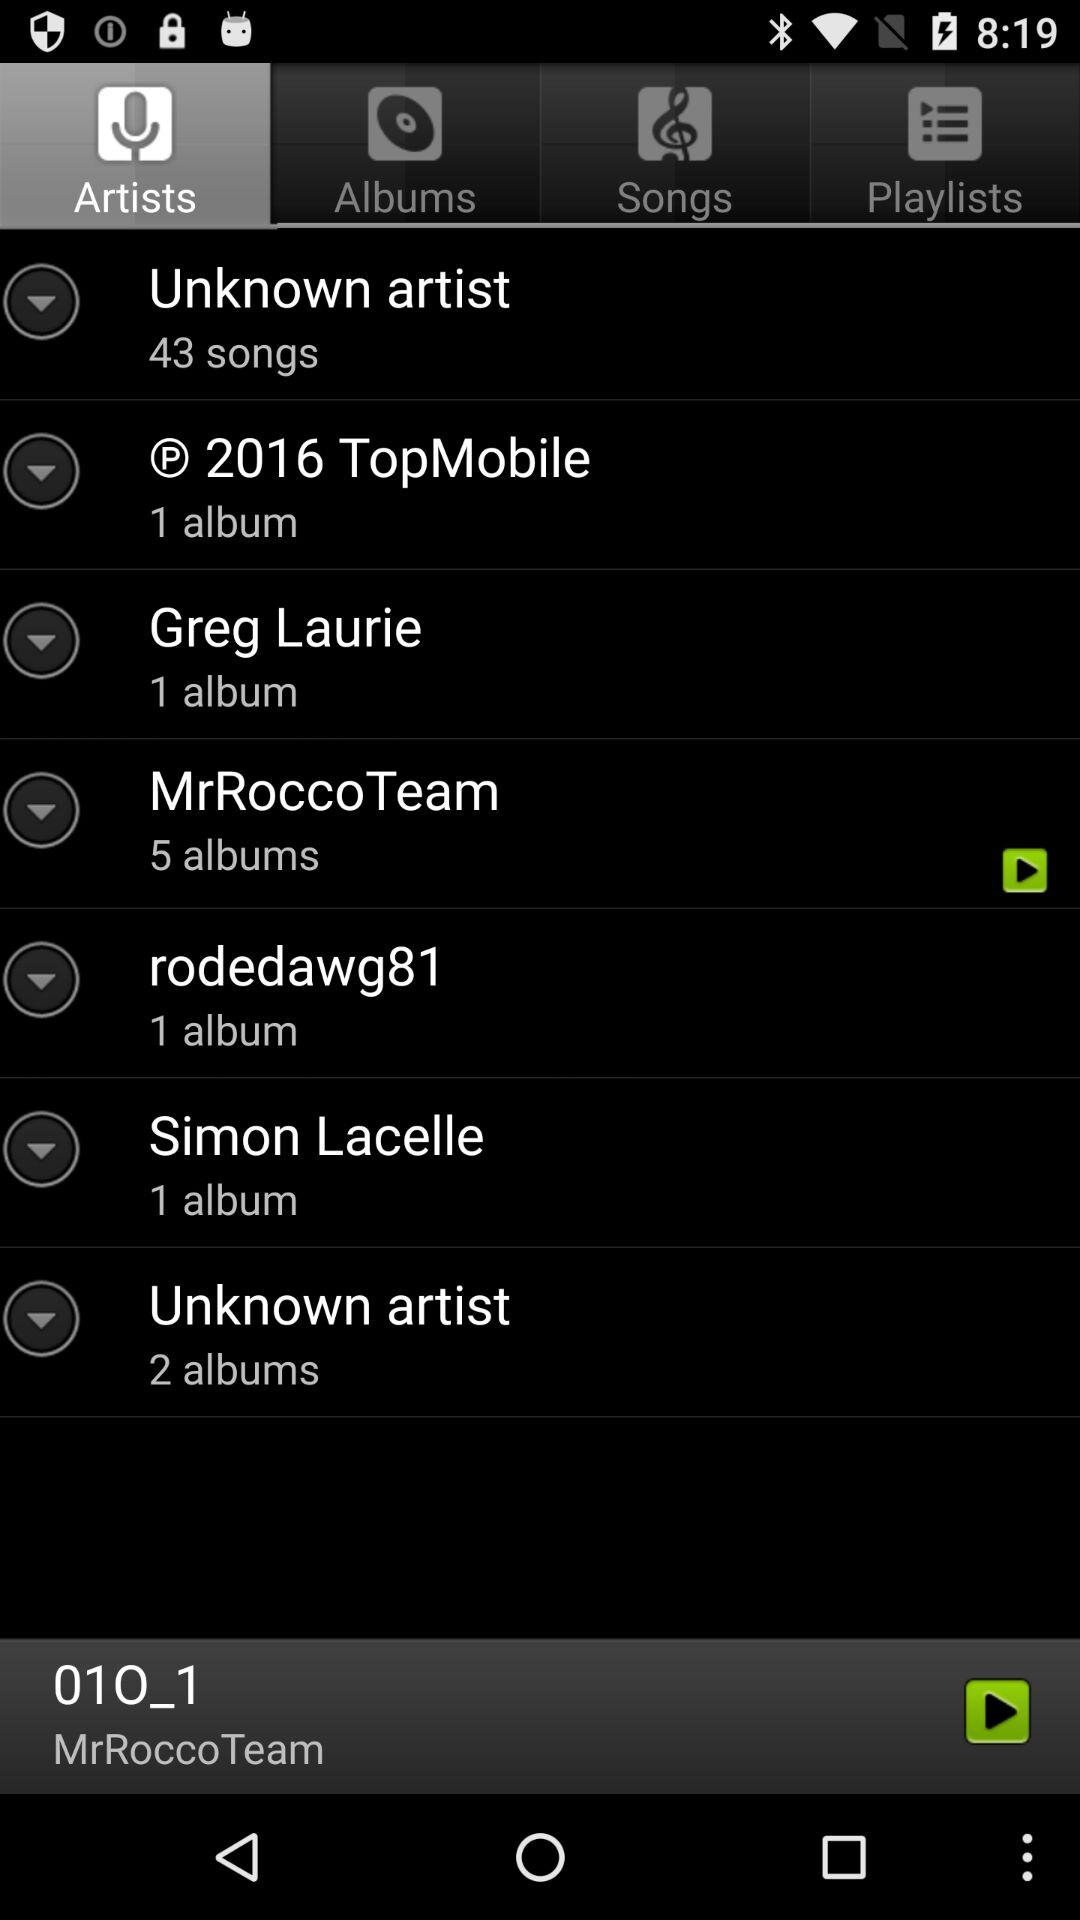Which tab is selected? The selected tab is "Artists". 